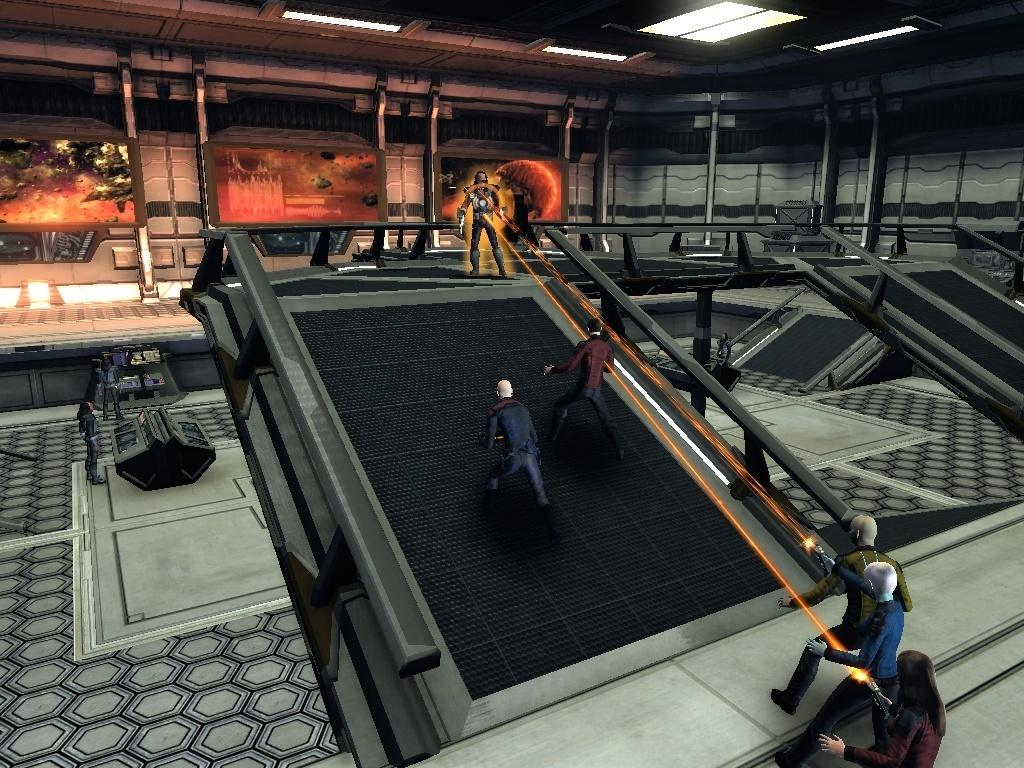What type of image is being described? The image is an animated depiction of a game. What are the persons in the game doing? The persons in the game are holding objects. What is the objective or action in the game? The game involves staring, which causes lights to appear on the roof. What type of sheet is used by the cook in the image? There is no cook or sheet present in the image; it is an animated depiction of a game involving staring and lights on the roof. 